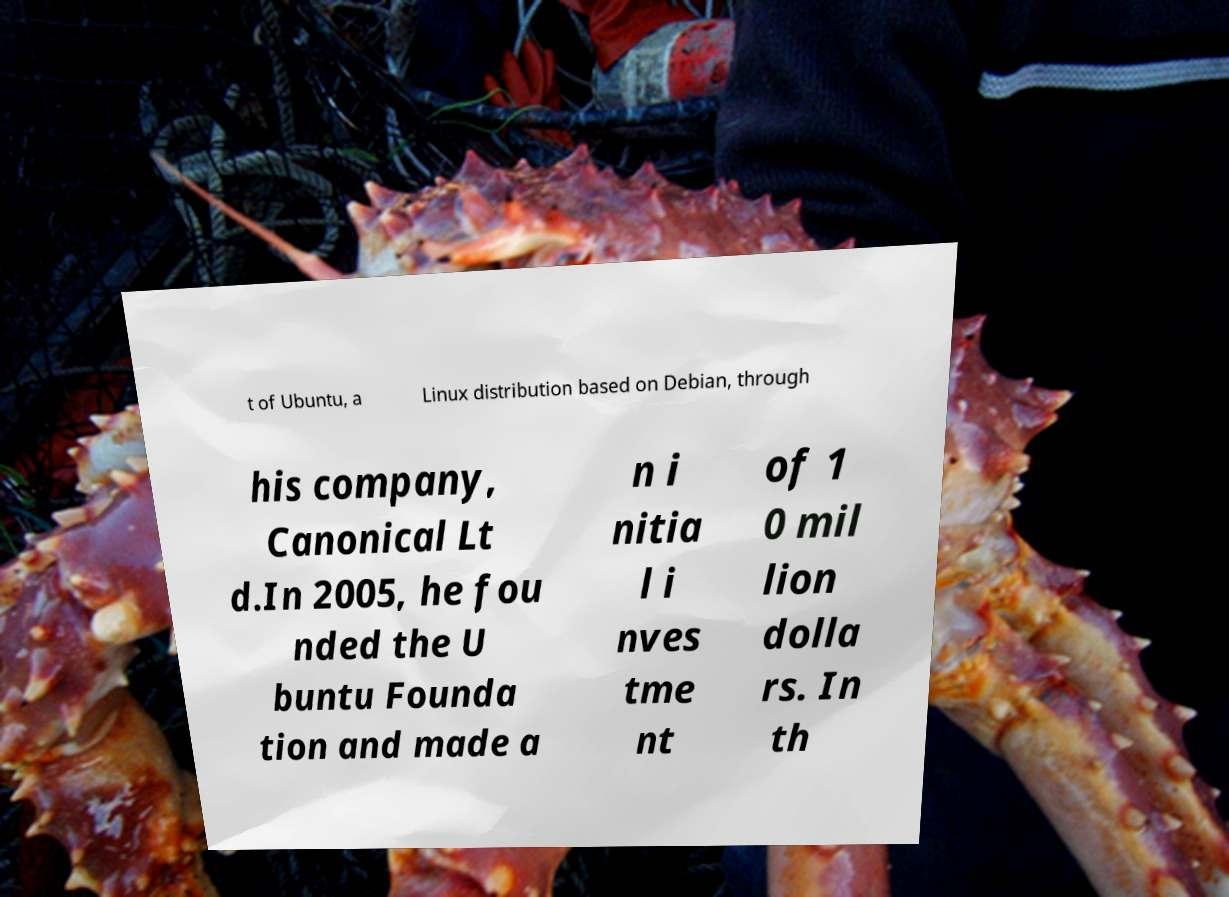There's text embedded in this image that I need extracted. Can you transcribe it verbatim? t of Ubuntu, a Linux distribution based on Debian, through his company, Canonical Lt d.In 2005, he fou nded the U buntu Founda tion and made a n i nitia l i nves tme nt of 1 0 mil lion dolla rs. In th 